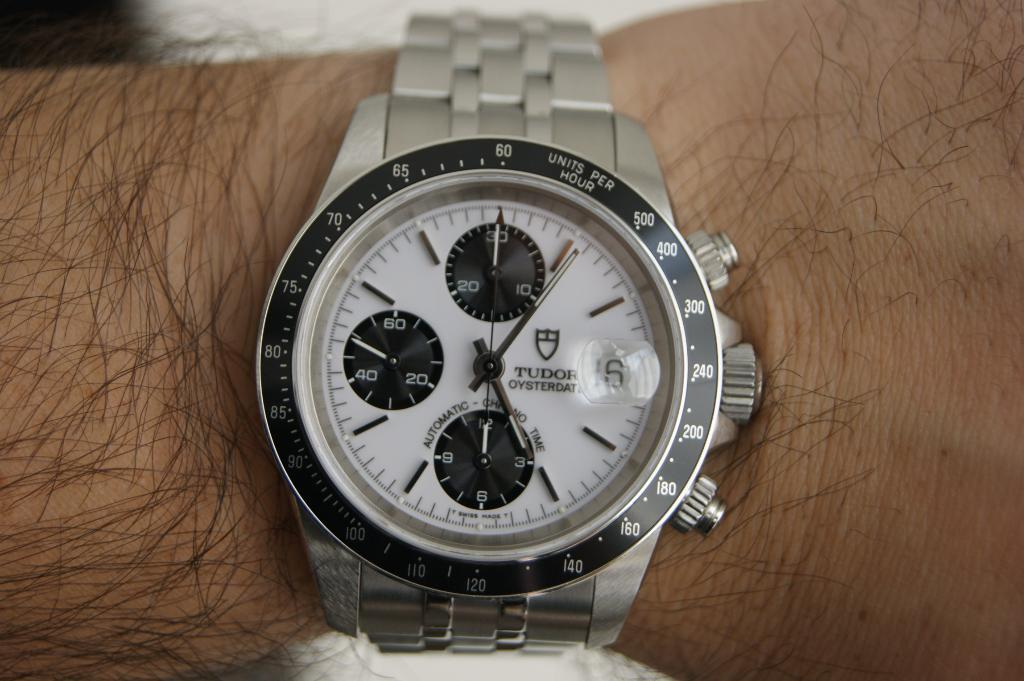Provide a one-sentence caption for the provided image. A silver Tudor wrist watch is wrapped around a hairy wrist. 